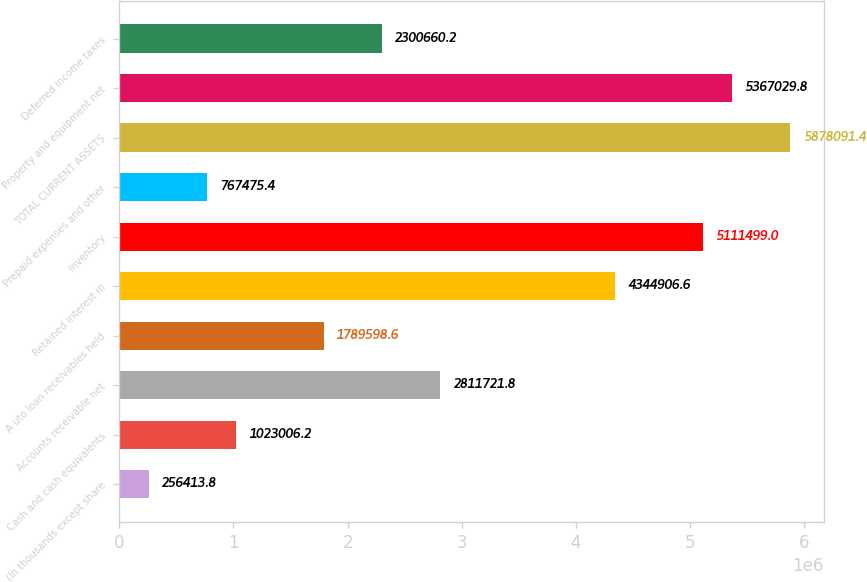Convert chart. <chart><loc_0><loc_0><loc_500><loc_500><bar_chart><fcel>(In thousands except share<fcel>Cash and cash equivalents<fcel>Accounts receivable net<fcel>A uto loan receivables held<fcel>Retained interest in<fcel>Inventory<fcel>Prepaid expenses and other<fcel>TOTAL CURRENT ASSETS<fcel>Property and equipment net<fcel>Deferred income taxes<nl><fcel>256414<fcel>1.02301e+06<fcel>2.81172e+06<fcel>1.7896e+06<fcel>4.34491e+06<fcel>5.1115e+06<fcel>767475<fcel>5.87809e+06<fcel>5.36703e+06<fcel>2.30066e+06<nl></chart> 